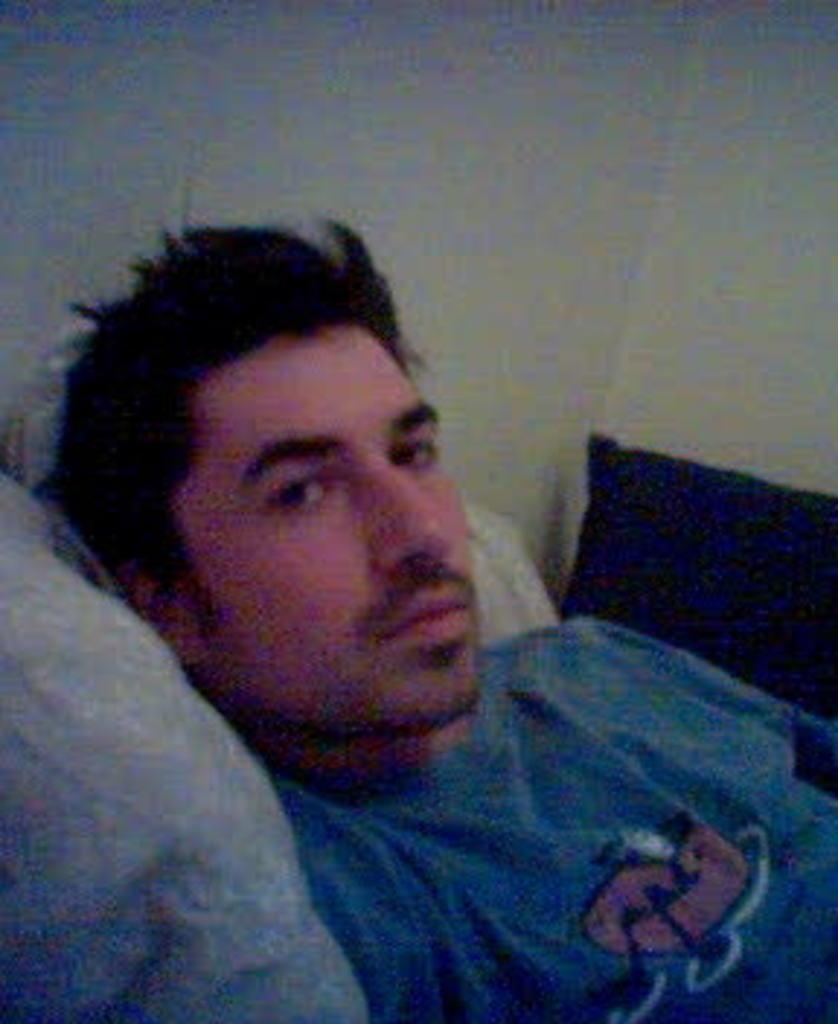What is present in the image? There is a man and pillows in the image. Can you describe the setting of the image? There is a wall in the background of the image. What type of secretary can be seen in the image? There is no secretary present in the image. Is there a flame visible in the image? There is no flame present in the image. 